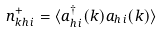<formula> <loc_0><loc_0><loc_500><loc_500>n ^ { + } _ { k h \, i } = \langle a ^ { \dagger } _ { h \, i } ( k ) a _ { h \, i } ( k ) \rangle</formula> 